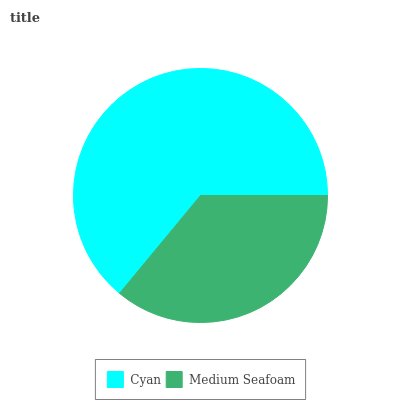Is Medium Seafoam the minimum?
Answer yes or no. Yes. Is Cyan the maximum?
Answer yes or no. Yes. Is Medium Seafoam the maximum?
Answer yes or no. No. Is Cyan greater than Medium Seafoam?
Answer yes or no. Yes. Is Medium Seafoam less than Cyan?
Answer yes or no. Yes. Is Medium Seafoam greater than Cyan?
Answer yes or no. No. Is Cyan less than Medium Seafoam?
Answer yes or no. No. Is Cyan the high median?
Answer yes or no. Yes. Is Medium Seafoam the low median?
Answer yes or no. Yes. Is Medium Seafoam the high median?
Answer yes or no. No. Is Cyan the low median?
Answer yes or no. No. 